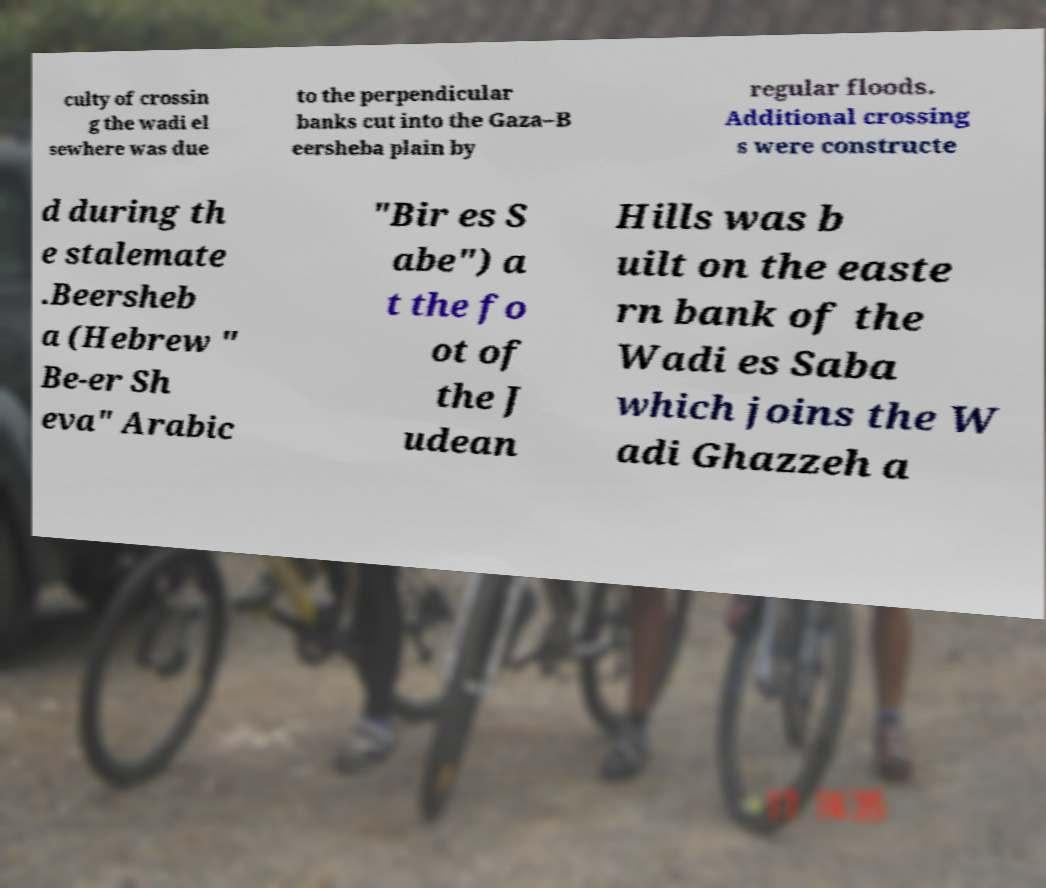Please identify and transcribe the text found in this image. culty of crossin g the wadi el sewhere was due to the perpendicular banks cut into the Gaza–B eersheba plain by regular floods. Additional crossing s were constructe d during th e stalemate .Beersheb a (Hebrew " Be-er Sh eva" Arabic "Bir es S abe") a t the fo ot of the J udean Hills was b uilt on the easte rn bank of the Wadi es Saba which joins the W adi Ghazzeh a 